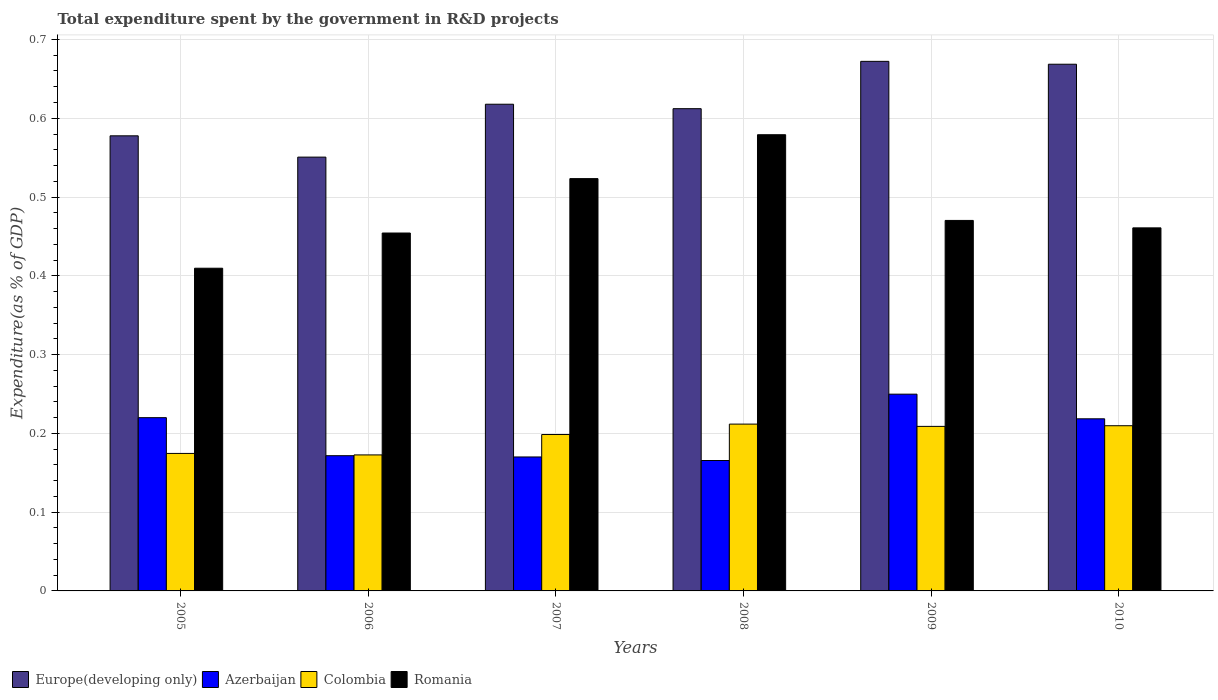Are the number of bars on each tick of the X-axis equal?
Your response must be concise. Yes. How many bars are there on the 2nd tick from the right?
Offer a very short reply. 4. What is the label of the 6th group of bars from the left?
Your response must be concise. 2010. In how many cases, is the number of bars for a given year not equal to the number of legend labels?
Your response must be concise. 0. What is the total expenditure spent by the government in R&D projects in Colombia in 2008?
Offer a very short reply. 0.21. Across all years, what is the maximum total expenditure spent by the government in R&D projects in Colombia?
Make the answer very short. 0.21. Across all years, what is the minimum total expenditure spent by the government in R&D projects in Europe(developing only)?
Provide a succinct answer. 0.55. In which year was the total expenditure spent by the government in R&D projects in Romania maximum?
Your answer should be very brief. 2008. In which year was the total expenditure spent by the government in R&D projects in Europe(developing only) minimum?
Provide a short and direct response. 2006. What is the total total expenditure spent by the government in R&D projects in Colombia in the graph?
Make the answer very short. 1.18. What is the difference between the total expenditure spent by the government in R&D projects in Colombia in 2005 and that in 2009?
Make the answer very short. -0.03. What is the difference between the total expenditure spent by the government in R&D projects in Romania in 2010 and the total expenditure spent by the government in R&D projects in Europe(developing only) in 2009?
Ensure brevity in your answer.  -0.21. What is the average total expenditure spent by the government in R&D projects in Romania per year?
Give a very brief answer. 0.48. In the year 2006, what is the difference between the total expenditure spent by the government in R&D projects in Europe(developing only) and total expenditure spent by the government in R&D projects in Romania?
Offer a terse response. 0.1. What is the ratio of the total expenditure spent by the government in R&D projects in Colombia in 2007 to that in 2010?
Provide a short and direct response. 0.95. What is the difference between the highest and the second highest total expenditure spent by the government in R&D projects in Romania?
Provide a short and direct response. 0.06. What is the difference between the highest and the lowest total expenditure spent by the government in R&D projects in Colombia?
Ensure brevity in your answer.  0.04. In how many years, is the total expenditure spent by the government in R&D projects in Romania greater than the average total expenditure spent by the government in R&D projects in Romania taken over all years?
Provide a short and direct response. 2. Is the sum of the total expenditure spent by the government in R&D projects in Colombia in 2005 and 2006 greater than the maximum total expenditure spent by the government in R&D projects in Europe(developing only) across all years?
Your response must be concise. No. Is it the case that in every year, the sum of the total expenditure spent by the government in R&D projects in Colombia and total expenditure spent by the government in R&D projects in Europe(developing only) is greater than the sum of total expenditure spent by the government in R&D projects in Romania and total expenditure spent by the government in R&D projects in Azerbaijan?
Give a very brief answer. No. What does the 2nd bar from the left in 2010 represents?
Your answer should be very brief. Azerbaijan. What does the 3rd bar from the right in 2007 represents?
Your answer should be very brief. Azerbaijan. Is it the case that in every year, the sum of the total expenditure spent by the government in R&D projects in Azerbaijan and total expenditure spent by the government in R&D projects in Europe(developing only) is greater than the total expenditure spent by the government in R&D projects in Colombia?
Your answer should be compact. Yes. How many bars are there?
Your response must be concise. 24. Are all the bars in the graph horizontal?
Your answer should be compact. No. Where does the legend appear in the graph?
Keep it short and to the point. Bottom left. What is the title of the graph?
Provide a succinct answer. Total expenditure spent by the government in R&D projects. Does "World" appear as one of the legend labels in the graph?
Make the answer very short. No. What is the label or title of the Y-axis?
Your response must be concise. Expenditure(as % of GDP). What is the Expenditure(as % of GDP) in Europe(developing only) in 2005?
Give a very brief answer. 0.58. What is the Expenditure(as % of GDP) of Azerbaijan in 2005?
Ensure brevity in your answer.  0.22. What is the Expenditure(as % of GDP) in Colombia in 2005?
Ensure brevity in your answer.  0.17. What is the Expenditure(as % of GDP) in Romania in 2005?
Offer a very short reply. 0.41. What is the Expenditure(as % of GDP) of Europe(developing only) in 2006?
Make the answer very short. 0.55. What is the Expenditure(as % of GDP) of Azerbaijan in 2006?
Make the answer very short. 0.17. What is the Expenditure(as % of GDP) in Colombia in 2006?
Offer a very short reply. 0.17. What is the Expenditure(as % of GDP) of Romania in 2006?
Your response must be concise. 0.45. What is the Expenditure(as % of GDP) in Europe(developing only) in 2007?
Your answer should be compact. 0.62. What is the Expenditure(as % of GDP) in Azerbaijan in 2007?
Your answer should be very brief. 0.17. What is the Expenditure(as % of GDP) of Colombia in 2007?
Offer a terse response. 0.2. What is the Expenditure(as % of GDP) in Romania in 2007?
Provide a short and direct response. 0.52. What is the Expenditure(as % of GDP) of Europe(developing only) in 2008?
Offer a very short reply. 0.61. What is the Expenditure(as % of GDP) of Azerbaijan in 2008?
Make the answer very short. 0.17. What is the Expenditure(as % of GDP) of Colombia in 2008?
Keep it short and to the point. 0.21. What is the Expenditure(as % of GDP) in Romania in 2008?
Your response must be concise. 0.58. What is the Expenditure(as % of GDP) in Europe(developing only) in 2009?
Your answer should be compact. 0.67. What is the Expenditure(as % of GDP) of Azerbaijan in 2009?
Keep it short and to the point. 0.25. What is the Expenditure(as % of GDP) of Colombia in 2009?
Provide a short and direct response. 0.21. What is the Expenditure(as % of GDP) in Romania in 2009?
Keep it short and to the point. 0.47. What is the Expenditure(as % of GDP) in Europe(developing only) in 2010?
Your answer should be compact. 0.67. What is the Expenditure(as % of GDP) of Azerbaijan in 2010?
Ensure brevity in your answer.  0.22. What is the Expenditure(as % of GDP) in Colombia in 2010?
Make the answer very short. 0.21. What is the Expenditure(as % of GDP) of Romania in 2010?
Keep it short and to the point. 0.46. Across all years, what is the maximum Expenditure(as % of GDP) in Europe(developing only)?
Provide a short and direct response. 0.67. Across all years, what is the maximum Expenditure(as % of GDP) of Azerbaijan?
Offer a terse response. 0.25. Across all years, what is the maximum Expenditure(as % of GDP) in Colombia?
Provide a short and direct response. 0.21. Across all years, what is the maximum Expenditure(as % of GDP) in Romania?
Provide a short and direct response. 0.58. Across all years, what is the minimum Expenditure(as % of GDP) in Europe(developing only)?
Make the answer very short. 0.55. Across all years, what is the minimum Expenditure(as % of GDP) in Azerbaijan?
Ensure brevity in your answer.  0.17. Across all years, what is the minimum Expenditure(as % of GDP) of Colombia?
Offer a terse response. 0.17. Across all years, what is the minimum Expenditure(as % of GDP) of Romania?
Offer a very short reply. 0.41. What is the total Expenditure(as % of GDP) of Europe(developing only) in the graph?
Your answer should be compact. 3.7. What is the total Expenditure(as % of GDP) of Azerbaijan in the graph?
Make the answer very short. 1.2. What is the total Expenditure(as % of GDP) in Colombia in the graph?
Offer a terse response. 1.18. What is the total Expenditure(as % of GDP) of Romania in the graph?
Your response must be concise. 2.9. What is the difference between the Expenditure(as % of GDP) in Europe(developing only) in 2005 and that in 2006?
Your answer should be very brief. 0.03. What is the difference between the Expenditure(as % of GDP) of Azerbaijan in 2005 and that in 2006?
Your response must be concise. 0.05. What is the difference between the Expenditure(as % of GDP) in Colombia in 2005 and that in 2006?
Ensure brevity in your answer.  0. What is the difference between the Expenditure(as % of GDP) in Romania in 2005 and that in 2006?
Your response must be concise. -0.04. What is the difference between the Expenditure(as % of GDP) in Europe(developing only) in 2005 and that in 2007?
Offer a very short reply. -0.04. What is the difference between the Expenditure(as % of GDP) in Azerbaijan in 2005 and that in 2007?
Give a very brief answer. 0.05. What is the difference between the Expenditure(as % of GDP) in Colombia in 2005 and that in 2007?
Offer a terse response. -0.02. What is the difference between the Expenditure(as % of GDP) in Romania in 2005 and that in 2007?
Give a very brief answer. -0.11. What is the difference between the Expenditure(as % of GDP) in Europe(developing only) in 2005 and that in 2008?
Provide a succinct answer. -0.03. What is the difference between the Expenditure(as % of GDP) in Azerbaijan in 2005 and that in 2008?
Keep it short and to the point. 0.05. What is the difference between the Expenditure(as % of GDP) of Colombia in 2005 and that in 2008?
Make the answer very short. -0.04. What is the difference between the Expenditure(as % of GDP) of Romania in 2005 and that in 2008?
Make the answer very short. -0.17. What is the difference between the Expenditure(as % of GDP) in Europe(developing only) in 2005 and that in 2009?
Keep it short and to the point. -0.09. What is the difference between the Expenditure(as % of GDP) of Azerbaijan in 2005 and that in 2009?
Keep it short and to the point. -0.03. What is the difference between the Expenditure(as % of GDP) in Colombia in 2005 and that in 2009?
Give a very brief answer. -0.03. What is the difference between the Expenditure(as % of GDP) in Romania in 2005 and that in 2009?
Provide a short and direct response. -0.06. What is the difference between the Expenditure(as % of GDP) of Europe(developing only) in 2005 and that in 2010?
Your response must be concise. -0.09. What is the difference between the Expenditure(as % of GDP) of Azerbaijan in 2005 and that in 2010?
Make the answer very short. 0. What is the difference between the Expenditure(as % of GDP) of Colombia in 2005 and that in 2010?
Give a very brief answer. -0.04. What is the difference between the Expenditure(as % of GDP) in Romania in 2005 and that in 2010?
Your response must be concise. -0.05. What is the difference between the Expenditure(as % of GDP) of Europe(developing only) in 2006 and that in 2007?
Give a very brief answer. -0.07. What is the difference between the Expenditure(as % of GDP) in Azerbaijan in 2006 and that in 2007?
Offer a very short reply. 0. What is the difference between the Expenditure(as % of GDP) in Colombia in 2006 and that in 2007?
Your answer should be compact. -0.03. What is the difference between the Expenditure(as % of GDP) in Romania in 2006 and that in 2007?
Offer a very short reply. -0.07. What is the difference between the Expenditure(as % of GDP) of Europe(developing only) in 2006 and that in 2008?
Your answer should be very brief. -0.06. What is the difference between the Expenditure(as % of GDP) of Azerbaijan in 2006 and that in 2008?
Keep it short and to the point. 0.01. What is the difference between the Expenditure(as % of GDP) of Colombia in 2006 and that in 2008?
Offer a very short reply. -0.04. What is the difference between the Expenditure(as % of GDP) of Romania in 2006 and that in 2008?
Your response must be concise. -0.12. What is the difference between the Expenditure(as % of GDP) of Europe(developing only) in 2006 and that in 2009?
Give a very brief answer. -0.12. What is the difference between the Expenditure(as % of GDP) in Azerbaijan in 2006 and that in 2009?
Offer a very short reply. -0.08. What is the difference between the Expenditure(as % of GDP) in Colombia in 2006 and that in 2009?
Your answer should be very brief. -0.04. What is the difference between the Expenditure(as % of GDP) in Romania in 2006 and that in 2009?
Your response must be concise. -0.02. What is the difference between the Expenditure(as % of GDP) in Europe(developing only) in 2006 and that in 2010?
Provide a succinct answer. -0.12. What is the difference between the Expenditure(as % of GDP) of Azerbaijan in 2006 and that in 2010?
Give a very brief answer. -0.05. What is the difference between the Expenditure(as % of GDP) in Colombia in 2006 and that in 2010?
Your response must be concise. -0.04. What is the difference between the Expenditure(as % of GDP) of Romania in 2006 and that in 2010?
Keep it short and to the point. -0.01. What is the difference between the Expenditure(as % of GDP) of Europe(developing only) in 2007 and that in 2008?
Ensure brevity in your answer.  0.01. What is the difference between the Expenditure(as % of GDP) of Azerbaijan in 2007 and that in 2008?
Keep it short and to the point. 0. What is the difference between the Expenditure(as % of GDP) in Colombia in 2007 and that in 2008?
Your response must be concise. -0.01. What is the difference between the Expenditure(as % of GDP) in Romania in 2007 and that in 2008?
Make the answer very short. -0.06. What is the difference between the Expenditure(as % of GDP) in Europe(developing only) in 2007 and that in 2009?
Provide a succinct answer. -0.05. What is the difference between the Expenditure(as % of GDP) of Azerbaijan in 2007 and that in 2009?
Keep it short and to the point. -0.08. What is the difference between the Expenditure(as % of GDP) in Colombia in 2007 and that in 2009?
Offer a very short reply. -0.01. What is the difference between the Expenditure(as % of GDP) in Romania in 2007 and that in 2009?
Offer a very short reply. 0.05. What is the difference between the Expenditure(as % of GDP) in Europe(developing only) in 2007 and that in 2010?
Offer a very short reply. -0.05. What is the difference between the Expenditure(as % of GDP) of Azerbaijan in 2007 and that in 2010?
Make the answer very short. -0.05. What is the difference between the Expenditure(as % of GDP) in Colombia in 2007 and that in 2010?
Your answer should be compact. -0.01. What is the difference between the Expenditure(as % of GDP) in Romania in 2007 and that in 2010?
Offer a terse response. 0.06. What is the difference between the Expenditure(as % of GDP) of Europe(developing only) in 2008 and that in 2009?
Provide a short and direct response. -0.06. What is the difference between the Expenditure(as % of GDP) in Azerbaijan in 2008 and that in 2009?
Your response must be concise. -0.08. What is the difference between the Expenditure(as % of GDP) in Colombia in 2008 and that in 2009?
Offer a very short reply. 0. What is the difference between the Expenditure(as % of GDP) of Romania in 2008 and that in 2009?
Your answer should be very brief. 0.11. What is the difference between the Expenditure(as % of GDP) of Europe(developing only) in 2008 and that in 2010?
Provide a succinct answer. -0.06. What is the difference between the Expenditure(as % of GDP) in Azerbaijan in 2008 and that in 2010?
Offer a very short reply. -0.05. What is the difference between the Expenditure(as % of GDP) of Colombia in 2008 and that in 2010?
Ensure brevity in your answer.  0. What is the difference between the Expenditure(as % of GDP) in Romania in 2008 and that in 2010?
Give a very brief answer. 0.12. What is the difference between the Expenditure(as % of GDP) of Europe(developing only) in 2009 and that in 2010?
Your answer should be very brief. 0. What is the difference between the Expenditure(as % of GDP) in Azerbaijan in 2009 and that in 2010?
Keep it short and to the point. 0.03. What is the difference between the Expenditure(as % of GDP) of Colombia in 2009 and that in 2010?
Your answer should be compact. -0. What is the difference between the Expenditure(as % of GDP) of Romania in 2009 and that in 2010?
Provide a short and direct response. 0.01. What is the difference between the Expenditure(as % of GDP) in Europe(developing only) in 2005 and the Expenditure(as % of GDP) in Azerbaijan in 2006?
Ensure brevity in your answer.  0.41. What is the difference between the Expenditure(as % of GDP) in Europe(developing only) in 2005 and the Expenditure(as % of GDP) in Colombia in 2006?
Provide a succinct answer. 0.41. What is the difference between the Expenditure(as % of GDP) in Europe(developing only) in 2005 and the Expenditure(as % of GDP) in Romania in 2006?
Keep it short and to the point. 0.12. What is the difference between the Expenditure(as % of GDP) of Azerbaijan in 2005 and the Expenditure(as % of GDP) of Colombia in 2006?
Your answer should be compact. 0.05. What is the difference between the Expenditure(as % of GDP) of Azerbaijan in 2005 and the Expenditure(as % of GDP) of Romania in 2006?
Your answer should be compact. -0.23. What is the difference between the Expenditure(as % of GDP) in Colombia in 2005 and the Expenditure(as % of GDP) in Romania in 2006?
Give a very brief answer. -0.28. What is the difference between the Expenditure(as % of GDP) in Europe(developing only) in 2005 and the Expenditure(as % of GDP) in Azerbaijan in 2007?
Ensure brevity in your answer.  0.41. What is the difference between the Expenditure(as % of GDP) in Europe(developing only) in 2005 and the Expenditure(as % of GDP) in Colombia in 2007?
Keep it short and to the point. 0.38. What is the difference between the Expenditure(as % of GDP) in Europe(developing only) in 2005 and the Expenditure(as % of GDP) in Romania in 2007?
Provide a short and direct response. 0.05. What is the difference between the Expenditure(as % of GDP) of Azerbaijan in 2005 and the Expenditure(as % of GDP) of Colombia in 2007?
Provide a short and direct response. 0.02. What is the difference between the Expenditure(as % of GDP) of Azerbaijan in 2005 and the Expenditure(as % of GDP) of Romania in 2007?
Your response must be concise. -0.3. What is the difference between the Expenditure(as % of GDP) in Colombia in 2005 and the Expenditure(as % of GDP) in Romania in 2007?
Offer a very short reply. -0.35. What is the difference between the Expenditure(as % of GDP) in Europe(developing only) in 2005 and the Expenditure(as % of GDP) in Azerbaijan in 2008?
Provide a succinct answer. 0.41. What is the difference between the Expenditure(as % of GDP) of Europe(developing only) in 2005 and the Expenditure(as % of GDP) of Colombia in 2008?
Your answer should be very brief. 0.37. What is the difference between the Expenditure(as % of GDP) of Europe(developing only) in 2005 and the Expenditure(as % of GDP) of Romania in 2008?
Ensure brevity in your answer.  -0. What is the difference between the Expenditure(as % of GDP) of Azerbaijan in 2005 and the Expenditure(as % of GDP) of Colombia in 2008?
Your answer should be very brief. 0.01. What is the difference between the Expenditure(as % of GDP) of Azerbaijan in 2005 and the Expenditure(as % of GDP) of Romania in 2008?
Provide a succinct answer. -0.36. What is the difference between the Expenditure(as % of GDP) of Colombia in 2005 and the Expenditure(as % of GDP) of Romania in 2008?
Your answer should be compact. -0.4. What is the difference between the Expenditure(as % of GDP) of Europe(developing only) in 2005 and the Expenditure(as % of GDP) of Azerbaijan in 2009?
Offer a terse response. 0.33. What is the difference between the Expenditure(as % of GDP) in Europe(developing only) in 2005 and the Expenditure(as % of GDP) in Colombia in 2009?
Keep it short and to the point. 0.37. What is the difference between the Expenditure(as % of GDP) in Europe(developing only) in 2005 and the Expenditure(as % of GDP) in Romania in 2009?
Offer a very short reply. 0.11. What is the difference between the Expenditure(as % of GDP) of Azerbaijan in 2005 and the Expenditure(as % of GDP) of Colombia in 2009?
Provide a short and direct response. 0.01. What is the difference between the Expenditure(as % of GDP) in Azerbaijan in 2005 and the Expenditure(as % of GDP) in Romania in 2009?
Offer a very short reply. -0.25. What is the difference between the Expenditure(as % of GDP) of Colombia in 2005 and the Expenditure(as % of GDP) of Romania in 2009?
Provide a succinct answer. -0.3. What is the difference between the Expenditure(as % of GDP) in Europe(developing only) in 2005 and the Expenditure(as % of GDP) in Azerbaijan in 2010?
Provide a succinct answer. 0.36. What is the difference between the Expenditure(as % of GDP) of Europe(developing only) in 2005 and the Expenditure(as % of GDP) of Colombia in 2010?
Give a very brief answer. 0.37. What is the difference between the Expenditure(as % of GDP) in Europe(developing only) in 2005 and the Expenditure(as % of GDP) in Romania in 2010?
Your response must be concise. 0.12. What is the difference between the Expenditure(as % of GDP) of Azerbaijan in 2005 and the Expenditure(as % of GDP) of Colombia in 2010?
Keep it short and to the point. 0.01. What is the difference between the Expenditure(as % of GDP) in Azerbaijan in 2005 and the Expenditure(as % of GDP) in Romania in 2010?
Your answer should be compact. -0.24. What is the difference between the Expenditure(as % of GDP) of Colombia in 2005 and the Expenditure(as % of GDP) of Romania in 2010?
Provide a succinct answer. -0.29. What is the difference between the Expenditure(as % of GDP) of Europe(developing only) in 2006 and the Expenditure(as % of GDP) of Azerbaijan in 2007?
Offer a very short reply. 0.38. What is the difference between the Expenditure(as % of GDP) of Europe(developing only) in 2006 and the Expenditure(as % of GDP) of Colombia in 2007?
Offer a terse response. 0.35. What is the difference between the Expenditure(as % of GDP) of Europe(developing only) in 2006 and the Expenditure(as % of GDP) of Romania in 2007?
Provide a short and direct response. 0.03. What is the difference between the Expenditure(as % of GDP) of Azerbaijan in 2006 and the Expenditure(as % of GDP) of Colombia in 2007?
Offer a terse response. -0.03. What is the difference between the Expenditure(as % of GDP) of Azerbaijan in 2006 and the Expenditure(as % of GDP) of Romania in 2007?
Ensure brevity in your answer.  -0.35. What is the difference between the Expenditure(as % of GDP) in Colombia in 2006 and the Expenditure(as % of GDP) in Romania in 2007?
Provide a short and direct response. -0.35. What is the difference between the Expenditure(as % of GDP) of Europe(developing only) in 2006 and the Expenditure(as % of GDP) of Azerbaijan in 2008?
Provide a succinct answer. 0.39. What is the difference between the Expenditure(as % of GDP) of Europe(developing only) in 2006 and the Expenditure(as % of GDP) of Colombia in 2008?
Offer a very short reply. 0.34. What is the difference between the Expenditure(as % of GDP) of Europe(developing only) in 2006 and the Expenditure(as % of GDP) of Romania in 2008?
Offer a very short reply. -0.03. What is the difference between the Expenditure(as % of GDP) of Azerbaijan in 2006 and the Expenditure(as % of GDP) of Colombia in 2008?
Offer a terse response. -0.04. What is the difference between the Expenditure(as % of GDP) in Azerbaijan in 2006 and the Expenditure(as % of GDP) in Romania in 2008?
Keep it short and to the point. -0.41. What is the difference between the Expenditure(as % of GDP) in Colombia in 2006 and the Expenditure(as % of GDP) in Romania in 2008?
Your response must be concise. -0.41. What is the difference between the Expenditure(as % of GDP) in Europe(developing only) in 2006 and the Expenditure(as % of GDP) in Azerbaijan in 2009?
Keep it short and to the point. 0.3. What is the difference between the Expenditure(as % of GDP) in Europe(developing only) in 2006 and the Expenditure(as % of GDP) in Colombia in 2009?
Provide a short and direct response. 0.34. What is the difference between the Expenditure(as % of GDP) of Europe(developing only) in 2006 and the Expenditure(as % of GDP) of Romania in 2009?
Your response must be concise. 0.08. What is the difference between the Expenditure(as % of GDP) in Azerbaijan in 2006 and the Expenditure(as % of GDP) in Colombia in 2009?
Make the answer very short. -0.04. What is the difference between the Expenditure(as % of GDP) of Azerbaijan in 2006 and the Expenditure(as % of GDP) of Romania in 2009?
Your response must be concise. -0.3. What is the difference between the Expenditure(as % of GDP) of Colombia in 2006 and the Expenditure(as % of GDP) of Romania in 2009?
Your answer should be very brief. -0.3. What is the difference between the Expenditure(as % of GDP) in Europe(developing only) in 2006 and the Expenditure(as % of GDP) in Azerbaijan in 2010?
Provide a succinct answer. 0.33. What is the difference between the Expenditure(as % of GDP) in Europe(developing only) in 2006 and the Expenditure(as % of GDP) in Colombia in 2010?
Ensure brevity in your answer.  0.34. What is the difference between the Expenditure(as % of GDP) in Europe(developing only) in 2006 and the Expenditure(as % of GDP) in Romania in 2010?
Your response must be concise. 0.09. What is the difference between the Expenditure(as % of GDP) in Azerbaijan in 2006 and the Expenditure(as % of GDP) in Colombia in 2010?
Give a very brief answer. -0.04. What is the difference between the Expenditure(as % of GDP) of Azerbaijan in 2006 and the Expenditure(as % of GDP) of Romania in 2010?
Your answer should be compact. -0.29. What is the difference between the Expenditure(as % of GDP) of Colombia in 2006 and the Expenditure(as % of GDP) of Romania in 2010?
Provide a succinct answer. -0.29. What is the difference between the Expenditure(as % of GDP) in Europe(developing only) in 2007 and the Expenditure(as % of GDP) in Azerbaijan in 2008?
Your answer should be compact. 0.45. What is the difference between the Expenditure(as % of GDP) of Europe(developing only) in 2007 and the Expenditure(as % of GDP) of Colombia in 2008?
Make the answer very short. 0.41. What is the difference between the Expenditure(as % of GDP) of Europe(developing only) in 2007 and the Expenditure(as % of GDP) of Romania in 2008?
Offer a very short reply. 0.04. What is the difference between the Expenditure(as % of GDP) in Azerbaijan in 2007 and the Expenditure(as % of GDP) in Colombia in 2008?
Your answer should be compact. -0.04. What is the difference between the Expenditure(as % of GDP) of Azerbaijan in 2007 and the Expenditure(as % of GDP) of Romania in 2008?
Your answer should be very brief. -0.41. What is the difference between the Expenditure(as % of GDP) of Colombia in 2007 and the Expenditure(as % of GDP) of Romania in 2008?
Your answer should be compact. -0.38. What is the difference between the Expenditure(as % of GDP) of Europe(developing only) in 2007 and the Expenditure(as % of GDP) of Azerbaijan in 2009?
Your answer should be compact. 0.37. What is the difference between the Expenditure(as % of GDP) in Europe(developing only) in 2007 and the Expenditure(as % of GDP) in Colombia in 2009?
Ensure brevity in your answer.  0.41. What is the difference between the Expenditure(as % of GDP) in Europe(developing only) in 2007 and the Expenditure(as % of GDP) in Romania in 2009?
Your answer should be compact. 0.15. What is the difference between the Expenditure(as % of GDP) in Azerbaijan in 2007 and the Expenditure(as % of GDP) in Colombia in 2009?
Offer a terse response. -0.04. What is the difference between the Expenditure(as % of GDP) in Azerbaijan in 2007 and the Expenditure(as % of GDP) in Romania in 2009?
Keep it short and to the point. -0.3. What is the difference between the Expenditure(as % of GDP) of Colombia in 2007 and the Expenditure(as % of GDP) of Romania in 2009?
Your response must be concise. -0.27. What is the difference between the Expenditure(as % of GDP) of Europe(developing only) in 2007 and the Expenditure(as % of GDP) of Azerbaijan in 2010?
Make the answer very short. 0.4. What is the difference between the Expenditure(as % of GDP) of Europe(developing only) in 2007 and the Expenditure(as % of GDP) of Colombia in 2010?
Give a very brief answer. 0.41. What is the difference between the Expenditure(as % of GDP) in Europe(developing only) in 2007 and the Expenditure(as % of GDP) in Romania in 2010?
Provide a short and direct response. 0.16. What is the difference between the Expenditure(as % of GDP) in Azerbaijan in 2007 and the Expenditure(as % of GDP) in Colombia in 2010?
Your answer should be very brief. -0.04. What is the difference between the Expenditure(as % of GDP) in Azerbaijan in 2007 and the Expenditure(as % of GDP) in Romania in 2010?
Make the answer very short. -0.29. What is the difference between the Expenditure(as % of GDP) of Colombia in 2007 and the Expenditure(as % of GDP) of Romania in 2010?
Provide a short and direct response. -0.26. What is the difference between the Expenditure(as % of GDP) in Europe(developing only) in 2008 and the Expenditure(as % of GDP) in Azerbaijan in 2009?
Your answer should be compact. 0.36. What is the difference between the Expenditure(as % of GDP) of Europe(developing only) in 2008 and the Expenditure(as % of GDP) of Colombia in 2009?
Give a very brief answer. 0.4. What is the difference between the Expenditure(as % of GDP) in Europe(developing only) in 2008 and the Expenditure(as % of GDP) in Romania in 2009?
Your response must be concise. 0.14. What is the difference between the Expenditure(as % of GDP) of Azerbaijan in 2008 and the Expenditure(as % of GDP) of Colombia in 2009?
Offer a very short reply. -0.04. What is the difference between the Expenditure(as % of GDP) in Azerbaijan in 2008 and the Expenditure(as % of GDP) in Romania in 2009?
Keep it short and to the point. -0.3. What is the difference between the Expenditure(as % of GDP) of Colombia in 2008 and the Expenditure(as % of GDP) of Romania in 2009?
Offer a very short reply. -0.26. What is the difference between the Expenditure(as % of GDP) of Europe(developing only) in 2008 and the Expenditure(as % of GDP) of Azerbaijan in 2010?
Give a very brief answer. 0.39. What is the difference between the Expenditure(as % of GDP) in Europe(developing only) in 2008 and the Expenditure(as % of GDP) in Colombia in 2010?
Keep it short and to the point. 0.4. What is the difference between the Expenditure(as % of GDP) in Europe(developing only) in 2008 and the Expenditure(as % of GDP) in Romania in 2010?
Your answer should be very brief. 0.15. What is the difference between the Expenditure(as % of GDP) of Azerbaijan in 2008 and the Expenditure(as % of GDP) of Colombia in 2010?
Keep it short and to the point. -0.04. What is the difference between the Expenditure(as % of GDP) in Azerbaijan in 2008 and the Expenditure(as % of GDP) in Romania in 2010?
Keep it short and to the point. -0.3. What is the difference between the Expenditure(as % of GDP) of Colombia in 2008 and the Expenditure(as % of GDP) of Romania in 2010?
Provide a succinct answer. -0.25. What is the difference between the Expenditure(as % of GDP) in Europe(developing only) in 2009 and the Expenditure(as % of GDP) in Azerbaijan in 2010?
Provide a short and direct response. 0.45. What is the difference between the Expenditure(as % of GDP) in Europe(developing only) in 2009 and the Expenditure(as % of GDP) in Colombia in 2010?
Offer a very short reply. 0.46. What is the difference between the Expenditure(as % of GDP) of Europe(developing only) in 2009 and the Expenditure(as % of GDP) of Romania in 2010?
Provide a short and direct response. 0.21. What is the difference between the Expenditure(as % of GDP) of Azerbaijan in 2009 and the Expenditure(as % of GDP) of Romania in 2010?
Provide a short and direct response. -0.21. What is the difference between the Expenditure(as % of GDP) of Colombia in 2009 and the Expenditure(as % of GDP) of Romania in 2010?
Your answer should be compact. -0.25. What is the average Expenditure(as % of GDP) of Europe(developing only) per year?
Ensure brevity in your answer.  0.62. What is the average Expenditure(as % of GDP) of Azerbaijan per year?
Give a very brief answer. 0.2. What is the average Expenditure(as % of GDP) in Colombia per year?
Your answer should be compact. 0.2. What is the average Expenditure(as % of GDP) in Romania per year?
Give a very brief answer. 0.48. In the year 2005, what is the difference between the Expenditure(as % of GDP) in Europe(developing only) and Expenditure(as % of GDP) in Azerbaijan?
Provide a succinct answer. 0.36. In the year 2005, what is the difference between the Expenditure(as % of GDP) of Europe(developing only) and Expenditure(as % of GDP) of Colombia?
Your response must be concise. 0.4. In the year 2005, what is the difference between the Expenditure(as % of GDP) of Europe(developing only) and Expenditure(as % of GDP) of Romania?
Your answer should be very brief. 0.17. In the year 2005, what is the difference between the Expenditure(as % of GDP) in Azerbaijan and Expenditure(as % of GDP) in Colombia?
Offer a terse response. 0.05. In the year 2005, what is the difference between the Expenditure(as % of GDP) of Azerbaijan and Expenditure(as % of GDP) of Romania?
Offer a terse response. -0.19. In the year 2005, what is the difference between the Expenditure(as % of GDP) in Colombia and Expenditure(as % of GDP) in Romania?
Your answer should be very brief. -0.24. In the year 2006, what is the difference between the Expenditure(as % of GDP) of Europe(developing only) and Expenditure(as % of GDP) of Azerbaijan?
Keep it short and to the point. 0.38. In the year 2006, what is the difference between the Expenditure(as % of GDP) in Europe(developing only) and Expenditure(as % of GDP) in Colombia?
Make the answer very short. 0.38. In the year 2006, what is the difference between the Expenditure(as % of GDP) in Europe(developing only) and Expenditure(as % of GDP) in Romania?
Offer a terse response. 0.1. In the year 2006, what is the difference between the Expenditure(as % of GDP) in Azerbaijan and Expenditure(as % of GDP) in Colombia?
Provide a succinct answer. -0. In the year 2006, what is the difference between the Expenditure(as % of GDP) in Azerbaijan and Expenditure(as % of GDP) in Romania?
Provide a succinct answer. -0.28. In the year 2006, what is the difference between the Expenditure(as % of GDP) in Colombia and Expenditure(as % of GDP) in Romania?
Your answer should be very brief. -0.28. In the year 2007, what is the difference between the Expenditure(as % of GDP) in Europe(developing only) and Expenditure(as % of GDP) in Azerbaijan?
Make the answer very short. 0.45. In the year 2007, what is the difference between the Expenditure(as % of GDP) of Europe(developing only) and Expenditure(as % of GDP) of Colombia?
Your answer should be compact. 0.42. In the year 2007, what is the difference between the Expenditure(as % of GDP) of Europe(developing only) and Expenditure(as % of GDP) of Romania?
Offer a terse response. 0.09. In the year 2007, what is the difference between the Expenditure(as % of GDP) of Azerbaijan and Expenditure(as % of GDP) of Colombia?
Provide a short and direct response. -0.03. In the year 2007, what is the difference between the Expenditure(as % of GDP) of Azerbaijan and Expenditure(as % of GDP) of Romania?
Keep it short and to the point. -0.35. In the year 2007, what is the difference between the Expenditure(as % of GDP) in Colombia and Expenditure(as % of GDP) in Romania?
Your response must be concise. -0.32. In the year 2008, what is the difference between the Expenditure(as % of GDP) of Europe(developing only) and Expenditure(as % of GDP) of Azerbaijan?
Provide a succinct answer. 0.45. In the year 2008, what is the difference between the Expenditure(as % of GDP) of Europe(developing only) and Expenditure(as % of GDP) of Colombia?
Keep it short and to the point. 0.4. In the year 2008, what is the difference between the Expenditure(as % of GDP) in Europe(developing only) and Expenditure(as % of GDP) in Romania?
Provide a succinct answer. 0.03. In the year 2008, what is the difference between the Expenditure(as % of GDP) in Azerbaijan and Expenditure(as % of GDP) in Colombia?
Your answer should be very brief. -0.05. In the year 2008, what is the difference between the Expenditure(as % of GDP) of Azerbaijan and Expenditure(as % of GDP) of Romania?
Offer a terse response. -0.41. In the year 2008, what is the difference between the Expenditure(as % of GDP) of Colombia and Expenditure(as % of GDP) of Romania?
Provide a succinct answer. -0.37. In the year 2009, what is the difference between the Expenditure(as % of GDP) of Europe(developing only) and Expenditure(as % of GDP) of Azerbaijan?
Make the answer very short. 0.42. In the year 2009, what is the difference between the Expenditure(as % of GDP) in Europe(developing only) and Expenditure(as % of GDP) in Colombia?
Your answer should be compact. 0.46. In the year 2009, what is the difference between the Expenditure(as % of GDP) of Europe(developing only) and Expenditure(as % of GDP) of Romania?
Your answer should be compact. 0.2. In the year 2009, what is the difference between the Expenditure(as % of GDP) of Azerbaijan and Expenditure(as % of GDP) of Colombia?
Keep it short and to the point. 0.04. In the year 2009, what is the difference between the Expenditure(as % of GDP) of Azerbaijan and Expenditure(as % of GDP) of Romania?
Offer a terse response. -0.22. In the year 2009, what is the difference between the Expenditure(as % of GDP) in Colombia and Expenditure(as % of GDP) in Romania?
Your answer should be very brief. -0.26. In the year 2010, what is the difference between the Expenditure(as % of GDP) in Europe(developing only) and Expenditure(as % of GDP) in Azerbaijan?
Provide a short and direct response. 0.45. In the year 2010, what is the difference between the Expenditure(as % of GDP) in Europe(developing only) and Expenditure(as % of GDP) in Colombia?
Your response must be concise. 0.46. In the year 2010, what is the difference between the Expenditure(as % of GDP) of Europe(developing only) and Expenditure(as % of GDP) of Romania?
Your answer should be compact. 0.21. In the year 2010, what is the difference between the Expenditure(as % of GDP) in Azerbaijan and Expenditure(as % of GDP) in Colombia?
Provide a short and direct response. 0.01. In the year 2010, what is the difference between the Expenditure(as % of GDP) of Azerbaijan and Expenditure(as % of GDP) of Romania?
Keep it short and to the point. -0.24. In the year 2010, what is the difference between the Expenditure(as % of GDP) in Colombia and Expenditure(as % of GDP) in Romania?
Offer a very short reply. -0.25. What is the ratio of the Expenditure(as % of GDP) of Europe(developing only) in 2005 to that in 2006?
Provide a short and direct response. 1.05. What is the ratio of the Expenditure(as % of GDP) of Azerbaijan in 2005 to that in 2006?
Give a very brief answer. 1.28. What is the ratio of the Expenditure(as % of GDP) of Colombia in 2005 to that in 2006?
Keep it short and to the point. 1.01. What is the ratio of the Expenditure(as % of GDP) in Romania in 2005 to that in 2006?
Your answer should be very brief. 0.9. What is the ratio of the Expenditure(as % of GDP) in Europe(developing only) in 2005 to that in 2007?
Your answer should be compact. 0.94. What is the ratio of the Expenditure(as % of GDP) in Azerbaijan in 2005 to that in 2007?
Your response must be concise. 1.29. What is the ratio of the Expenditure(as % of GDP) in Colombia in 2005 to that in 2007?
Make the answer very short. 0.88. What is the ratio of the Expenditure(as % of GDP) of Romania in 2005 to that in 2007?
Offer a terse response. 0.78. What is the ratio of the Expenditure(as % of GDP) in Europe(developing only) in 2005 to that in 2008?
Your answer should be very brief. 0.94. What is the ratio of the Expenditure(as % of GDP) of Azerbaijan in 2005 to that in 2008?
Your response must be concise. 1.33. What is the ratio of the Expenditure(as % of GDP) of Colombia in 2005 to that in 2008?
Offer a terse response. 0.82. What is the ratio of the Expenditure(as % of GDP) of Romania in 2005 to that in 2008?
Make the answer very short. 0.71. What is the ratio of the Expenditure(as % of GDP) of Europe(developing only) in 2005 to that in 2009?
Your answer should be very brief. 0.86. What is the ratio of the Expenditure(as % of GDP) of Azerbaijan in 2005 to that in 2009?
Provide a succinct answer. 0.88. What is the ratio of the Expenditure(as % of GDP) of Colombia in 2005 to that in 2009?
Keep it short and to the point. 0.84. What is the ratio of the Expenditure(as % of GDP) of Romania in 2005 to that in 2009?
Keep it short and to the point. 0.87. What is the ratio of the Expenditure(as % of GDP) of Europe(developing only) in 2005 to that in 2010?
Offer a terse response. 0.86. What is the ratio of the Expenditure(as % of GDP) of Colombia in 2005 to that in 2010?
Make the answer very short. 0.83. What is the ratio of the Expenditure(as % of GDP) of Europe(developing only) in 2006 to that in 2007?
Your answer should be very brief. 0.89. What is the ratio of the Expenditure(as % of GDP) in Azerbaijan in 2006 to that in 2007?
Keep it short and to the point. 1.01. What is the ratio of the Expenditure(as % of GDP) of Colombia in 2006 to that in 2007?
Provide a short and direct response. 0.87. What is the ratio of the Expenditure(as % of GDP) in Romania in 2006 to that in 2007?
Keep it short and to the point. 0.87. What is the ratio of the Expenditure(as % of GDP) in Europe(developing only) in 2006 to that in 2008?
Offer a terse response. 0.9. What is the ratio of the Expenditure(as % of GDP) in Azerbaijan in 2006 to that in 2008?
Keep it short and to the point. 1.04. What is the ratio of the Expenditure(as % of GDP) of Colombia in 2006 to that in 2008?
Ensure brevity in your answer.  0.82. What is the ratio of the Expenditure(as % of GDP) in Romania in 2006 to that in 2008?
Your response must be concise. 0.78. What is the ratio of the Expenditure(as % of GDP) of Europe(developing only) in 2006 to that in 2009?
Provide a short and direct response. 0.82. What is the ratio of the Expenditure(as % of GDP) in Azerbaijan in 2006 to that in 2009?
Keep it short and to the point. 0.69. What is the ratio of the Expenditure(as % of GDP) in Colombia in 2006 to that in 2009?
Your answer should be compact. 0.83. What is the ratio of the Expenditure(as % of GDP) in Europe(developing only) in 2006 to that in 2010?
Keep it short and to the point. 0.82. What is the ratio of the Expenditure(as % of GDP) in Azerbaijan in 2006 to that in 2010?
Provide a short and direct response. 0.79. What is the ratio of the Expenditure(as % of GDP) of Colombia in 2006 to that in 2010?
Give a very brief answer. 0.82. What is the ratio of the Expenditure(as % of GDP) in Romania in 2006 to that in 2010?
Make the answer very short. 0.99. What is the ratio of the Expenditure(as % of GDP) in Europe(developing only) in 2007 to that in 2008?
Provide a short and direct response. 1.01. What is the ratio of the Expenditure(as % of GDP) of Azerbaijan in 2007 to that in 2008?
Ensure brevity in your answer.  1.03. What is the ratio of the Expenditure(as % of GDP) in Romania in 2007 to that in 2008?
Make the answer very short. 0.9. What is the ratio of the Expenditure(as % of GDP) of Europe(developing only) in 2007 to that in 2009?
Give a very brief answer. 0.92. What is the ratio of the Expenditure(as % of GDP) of Azerbaijan in 2007 to that in 2009?
Ensure brevity in your answer.  0.68. What is the ratio of the Expenditure(as % of GDP) of Colombia in 2007 to that in 2009?
Ensure brevity in your answer.  0.95. What is the ratio of the Expenditure(as % of GDP) of Romania in 2007 to that in 2009?
Ensure brevity in your answer.  1.11. What is the ratio of the Expenditure(as % of GDP) in Europe(developing only) in 2007 to that in 2010?
Ensure brevity in your answer.  0.92. What is the ratio of the Expenditure(as % of GDP) in Azerbaijan in 2007 to that in 2010?
Your response must be concise. 0.78. What is the ratio of the Expenditure(as % of GDP) of Colombia in 2007 to that in 2010?
Your response must be concise. 0.95. What is the ratio of the Expenditure(as % of GDP) in Romania in 2007 to that in 2010?
Give a very brief answer. 1.14. What is the ratio of the Expenditure(as % of GDP) in Europe(developing only) in 2008 to that in 2009?
Provide a short and direct response. 0.91. What is the ratio of the Expenditure(as % of GDP) in Azerbaijan in 2008 to that in 2009?
Offer a very short reply. 0.66. What is the ratio of the Expenditure(as % of GDP) in Colombia in 2008 to that in 2009?
Provide a short and direct response. 1.01. What is the ratio of the Expenditure(as % of GDP) in Romania in 2008 to that in 2009?
Provide a short and direct response. 1.23. What is the ratio of the Expenditure(as % of GDP) of Europe(developing only) in 2008 to that in 2010?
Your answer should be compact. 0.92. What is the ratio of the Expenditure(as % of GDP) in Azerbaijan in 2008 to that in 2010?
Give a very brief answer. 0.76. What is the ratio of the Expenditure(as % of GDP) of Colombia in 2008 to that in 2010?
Provide a succinct answer. 1.01. What is the ratio of the Expenditure(as % of GDP) in Romania in 2008 to that in 2010?
Keep it short and to the point. 1.26. What is the ratio of the Expenditure(as % of GDP) in Europe(developing only) in 2009 to that in 2010?
Offer a very short reply. 1.01. What is the ratio of the Expenditure(as % of GDP) in Azerbaijan in 2009 to that in 2010?
Provide a short and direct response. 1.14. What is the ratio of the Expenditure(as % of GDP) of Colombia in 2009 to that in 2010?
Offer a very short reply. 1. What is the ratio of the Expenditure(as % of GDP) of Romania in 2009 to that in 2010?
Provide a short and direct response. 1.02. What is the difference between the highest and the second highest Expenditure(as % of GDP) in Europe(developing only)?
Keep it short and to the point. 0. What is the difference between the highest and the second highest Expenditure(as % of GDP) in Azerbaijan?
Offer a terse response. 0.03. What is the difference between the highest and the second highest Expenditure(as % of GDP) in Colombia?
Offer a terse response. 0. What is the difference between the highest and the second highest Expenditure(as % of GDP) of Romania?
Provide a short and direct response. 0.06. What is the difference between the highest and the lowest Expenditure(as % of GDP) in Europe(developing only)?
Your answer should be compact. 0.12. What is the difference between the highest and the lowest Expenditure(as % of GDP) in Azerbaijan?
Provide a succinct answer. 0.08. What is the difference between the highest and the lowest Expenditure(as % of GDP) of Colombia?
Your answer should be compact. 0.04. What is the difference between the highest and the lowest Expenditure(as % of GDP) in Romania?
Provide a short and direct response. 0.17. 